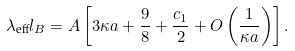<formula> <loc_0><loc_0><loc_500><loc_500>\lambda _ { \text {eff} } l _ { B } = A \left [ 3 \kappa a + \frac { 9 } { 8 } + \frac { c _ { 1 } } { 2 } + O \left ( \frac { 1 } { \kappa a } \right ) \right ] .</formula> 